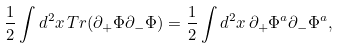Convert formula to latex. <formula><loc_0><loc_0><loc_500><loc_500>\frac { 1 } { 2 } \int d ^ { 2 } x \, T r ( \partial _ { + } \Phi \partial _ { - } \Phi ) = \frac { 1 } { 2 } \int d ^ { 2 } x \, \partial _ { + } \Phi ^ { a } \partial _ { - } \Phi ^ { a } ,</formula> 